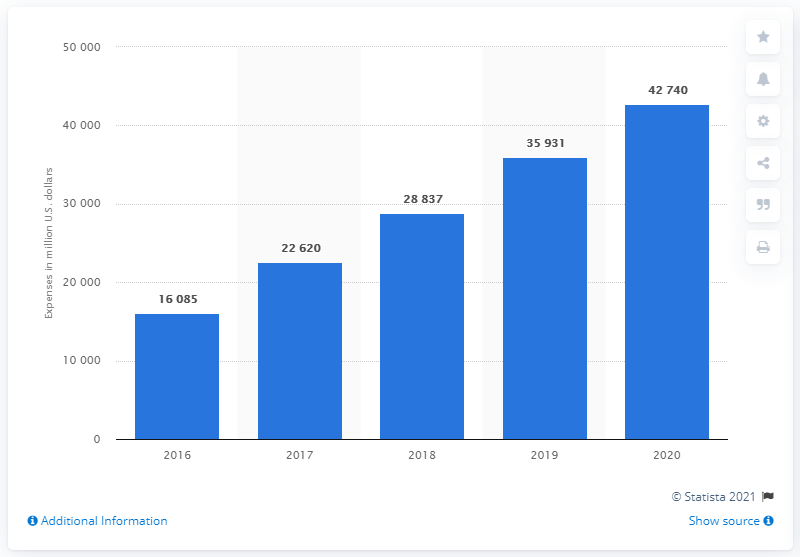Point out several critical features in this image. In 2020, Amazon's expenses for technology and content totaled $42,740. Amazon's technology and content expenses in the prior year were approximately $359,311. 